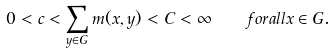Convert formula to latex. <formula><loc_0><loc_0><loc_500><loc_500>0 < c < \sum _ { y \in G } m ( x , y ) < C < \infty \quad f o r a l l x \in G .</formula> 